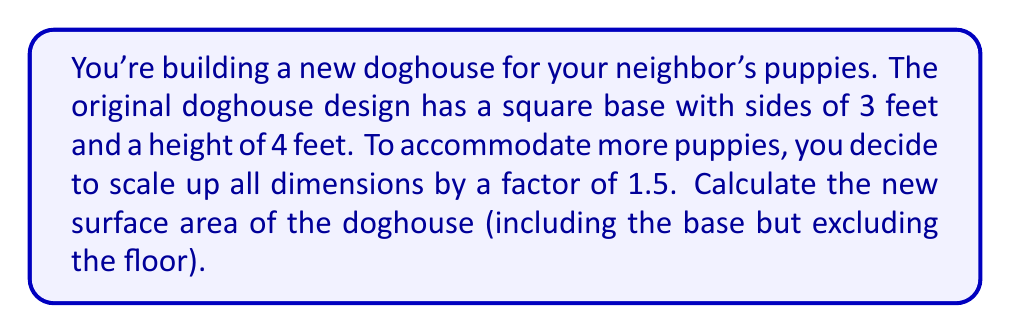Provide a solution to this math problem. Let's approach this step-by-step:

1) First, let's calculate the new dimensions after scaling:
   - New side length of base: $3 \times 1.5 = 4.5$ feet
   - New height: $4 \times 1.5 = 6$ feet

2) The doghouse consists of:
   - A square base (top)
   - Four rectangular sides

3) Calculate the area of the square base:
   $A_{base} = 4.5^2 = 20.25$ sq ft

4) Calculate the area of one rectangular side:
   $A_{side} = 4.5 \times 6 = 27$ sq ft

5) There are four identical sides, so multiply by 4:
   $A_{all sides} = 27 \times 4 = 108$ sq ft

6) Total surface area is the sum of the base and all sides:
   $A_{total} = A_{base} + A_{all sides} = 20.25 + 108 = 128.25$ sq ft

Therefore, the new surface area of the scaled-up doghouse is 128.25 square feet.
Answer: $128.25$ sq ft 